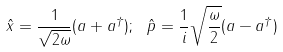<formula> <loc_0><loc_0><loc_500><loc_500>\hat { x } = \frac { 1 } { \sqrt { 2 \omega } } ( a + a ^ { \dag } ) ; \ \hat { p } = \frac { 1 } { i } \sqrt { \frac { \omega } { 2 } } ( a - a ^ { \dag } )</formula> 